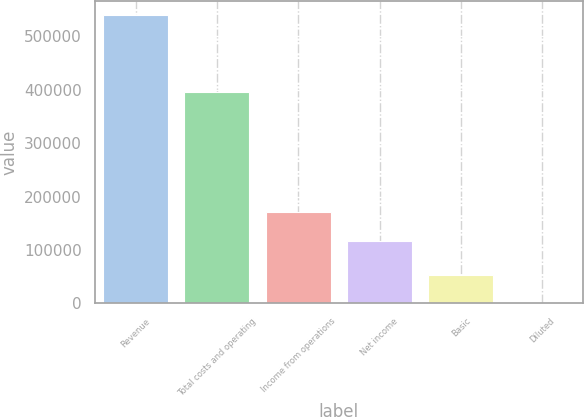<chart> <loc_0><loc_0><loc_500><loc_500><bar_chart><fcel>Revenue<fcel>Total costs and operating<fcel>Income from operations<fcel>Net income<fcel>Basic<fcel>Diluted<nl><fcel>539841<fcel>396206<fcel>170871<fcel>116887<fcel>53984.6<fcel>0.58<nl></chart> 